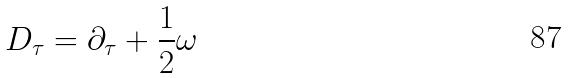<formula> <loc_0><loc_0><loc_500><loc_500>D _ { \tau } = \partial _ { \tau } + \frac { 1 } { 2 } \omega</formula> 